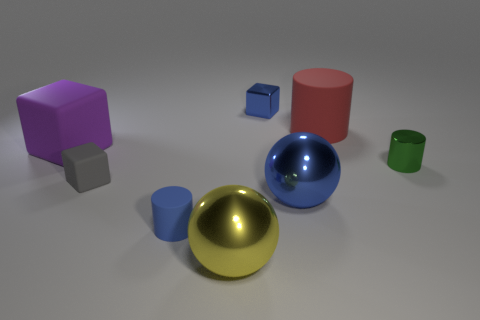There is a gray matte thing that is the same size as the blue shiny block; what is its shape? cube 